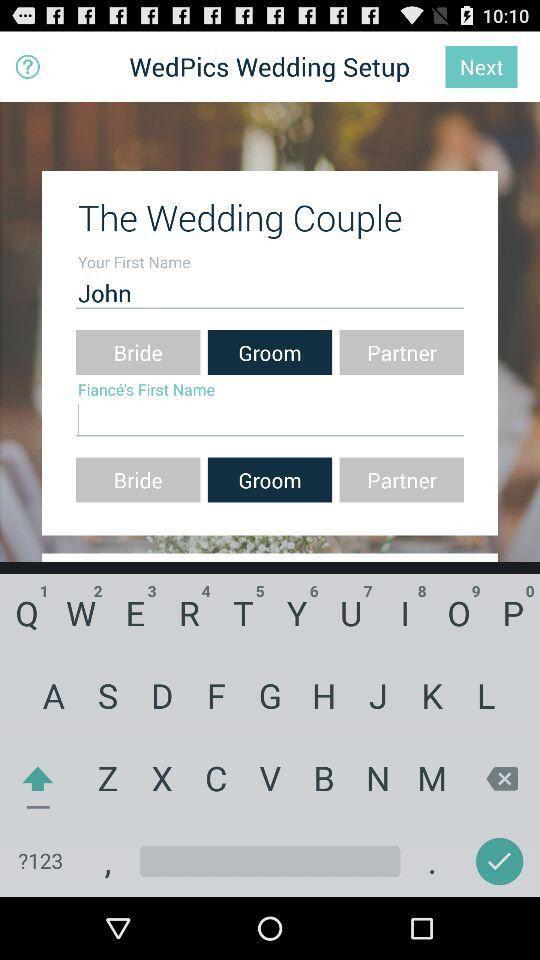What is the name of the user? The name of the user is John. 